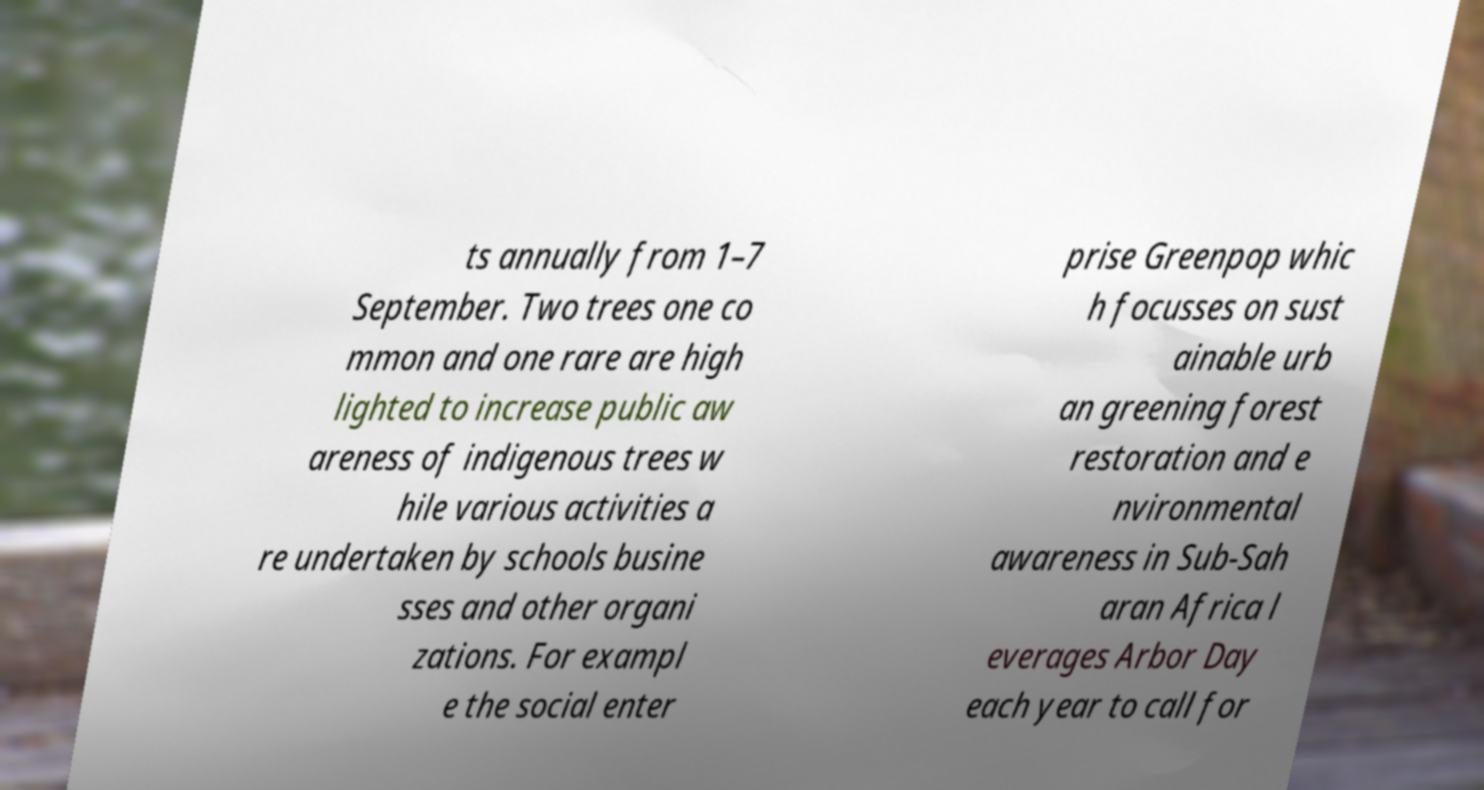Could you extract and type out the text from this image? ts annually from 1–7 September. Two trees one co mmon and one rare are high lighted to increase public aw areness of indigenous trees w hile various activities a re undertaken by schools busine sses and other organi zations. For exampl e the social enter prise Greenpop whic h focusses on sust ainable urb an greening forest restoration and e nvironmental awareness in Sub-Sah aran Africa l everages Arbor Day each year to call for 